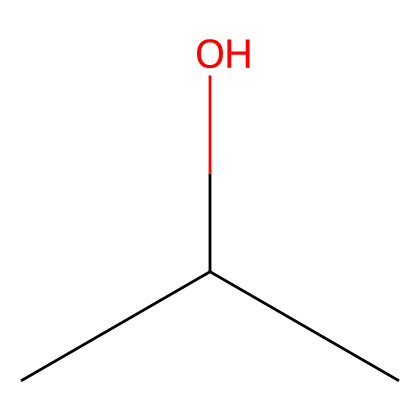What is the name of this chemical? The SMILES representation CC(C)O indicates a chemical structure with a central carbon atom bonded to three hydrogen atoms and one hydroxyl group (–OH), common in isopropyl alcohol.
Answer: isopropyl alcohol How many carbon atoms are in isopropyl alcohol? In the SMILES CC(C)O, there are three carbon atoms as indicated by the three 'C's present in the structure.
Answer: three What type of functional group is present in isopropyl alcohol? The presence of the –OH group in the chemical structure CC(C)O identifies it as an alcohol, which is characterized by the hydroxyl functional group.
Answer: alcohol What is the total number of hydrogen atoms in isopropyl alcohol? For the structure represented by CC(C)O, we have a total of seven hydrogen atoms: three from each of the carbon atoms and one from the hydroxyl group.
Answer: seven Why is isopropyl alcohol effective as a disinfectant? Isopropyl alcohol's molecular structure allows it to disrupt cell membranes of microbes and denature proteins, making it effective for disinfecting surfaces and equipment.
Answer: disrupt cell membranes What type of bond connects carbon and hydrogen in isopropyl alcohol? The bonds between carbon and hydrogen in isopropyl alcohol are covalent bonds, formed when the carbon atoms share electrons with hydrogen atoms.
Answer: covalent bonds 